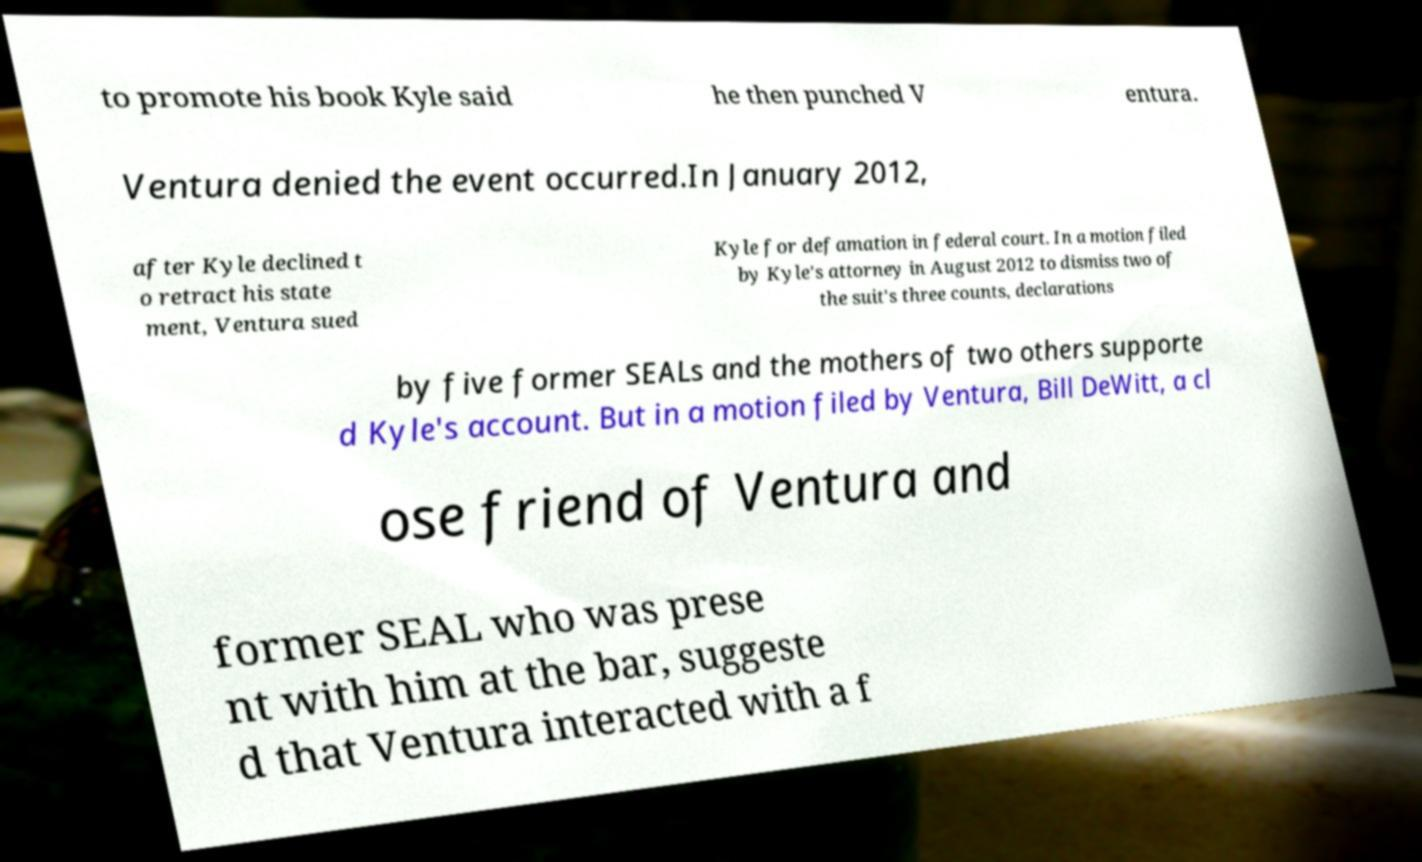Please read and relay the text visible in this image. What does it say? to promote his book Kyle said he then punched V entura. Ventura denied the event occurred.In January 2012, after Kyle declined t o retract his state ment, Ventura sued Kyle for defamation in federal court. In a motion filed by Kyle's attorney in August 2012 to dismiss two of the suit's three counts, declarations by five former SEALs and the mothers of two others supporte d Kyle's account. But in a motion filed by Ventura, Bill DeWitt, a cl ose friend of Ventura and former SEAL who was prese nt with him at the bar, suggeste d that Ventura interacted with a f 